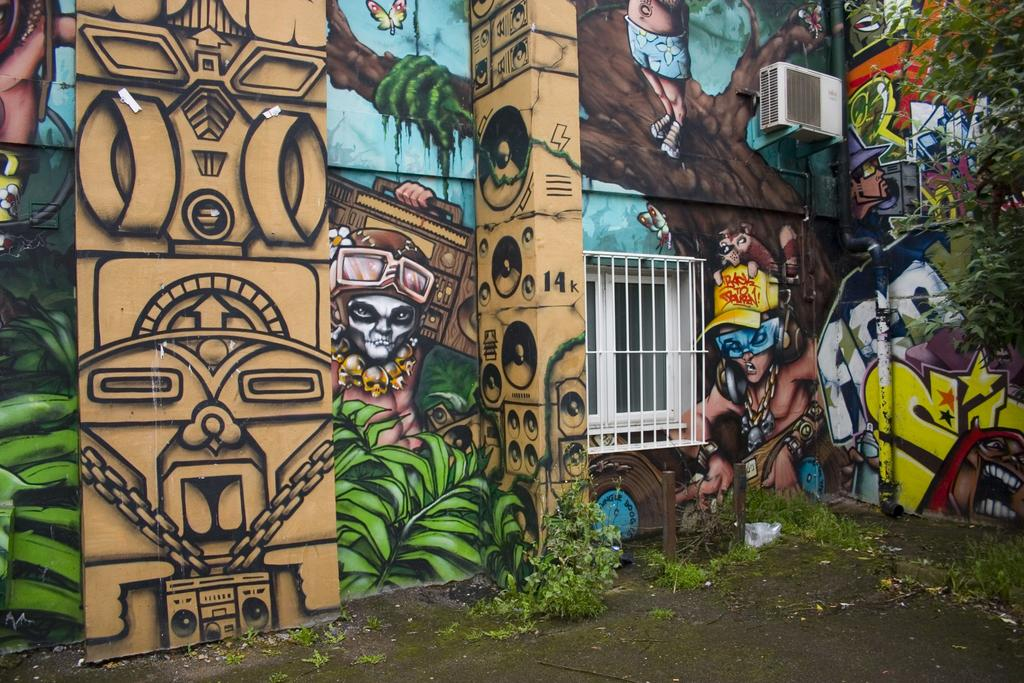What type of artwork can be seen on the walls in the image? There is a painting on the walls in the image. What architectural feature is present in the image? There is a window in the image. What type of vegetation is on the ground in the image? There are plants on the ground in the image. What type of utility is present in the image? There is a pipe in the image. What type of cooling system is present in the image? There is an air conditioning unit (AC) in the image. What type of natural element is present in the image? There is a tree in the image. Can you describe any other objects present in the image? There are other objects present in the image, but their specific details are not mentioned in the provided facts. How many chairs are visible in the image? There is no mention of chairs in the provided facts, so we cannot determine the number of chairs in the image. Is there a beetle crawling on the painting in the image? There is no mention of a beetle in the provided facts, so we cannot determine if there is a beetle in the image. 